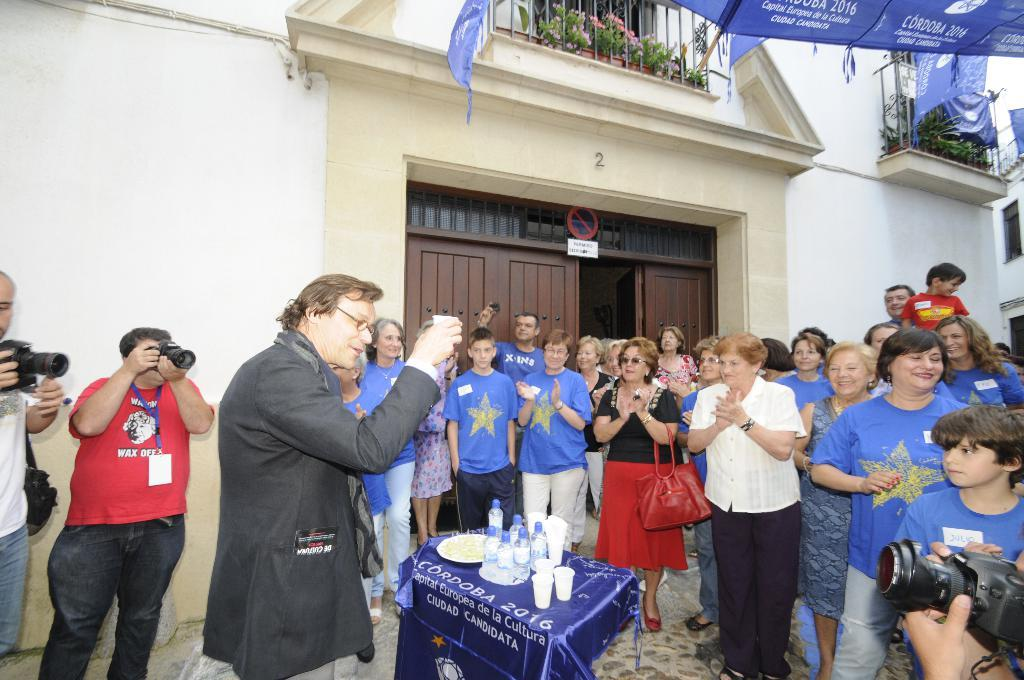How many people are in the image? There is a group of people in the image. Can you describe the man in the middle of the group? The man in the middle of the group is wearing a suit. What is in front of the man? There is a table in front of the man. What can be seen on the table? There are water bottles and cups on the table. Where is the alley where the group of people is resting in the image? There is no alley or resting activity depicted in the image; it shows a group of people with a man in the middle wearing a suit, a table in front of him, and water bottles and cups on the table. 